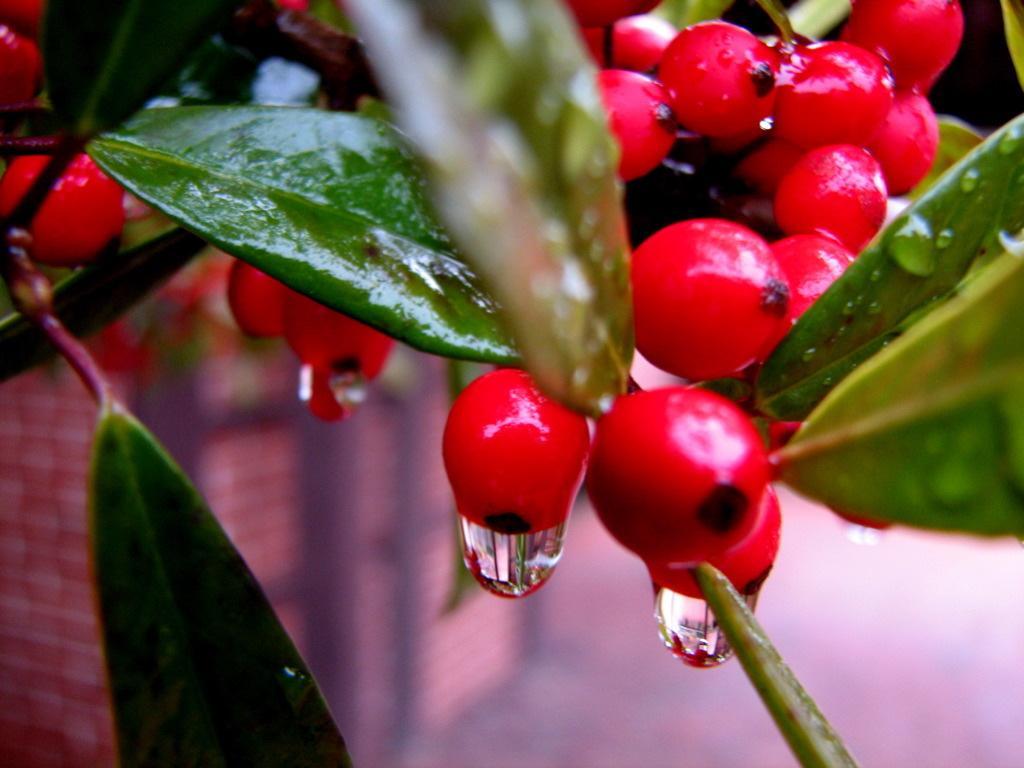How would you summarize this image in a sentence or two? In the picture we can see a plant with a leaf and some red color fruits from it, we can see water drops and under the plant we can see a wall which is not clearly visible. 